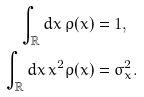Convert formula to latex. <formula><loc_0><loc_0><loc_500><loc_500>\int _ { \mathbb { R } } d x \, \rho ( x ) & = 1 , \\ \int _ { \mathbb { R } } d x \, x ^ { 2 } \rho ( x ) & = \sigma _ { x } ^ { 2 } .</formula> 